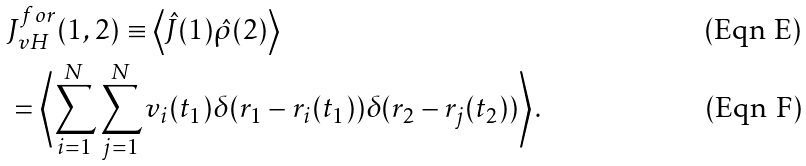Convert formula to latex. <formula><loc_0><loc_0><loc_500><loc_500>& J _ { v H } ^ { f o r } ( 1 , 2 ) \equiv \left \langle \hat { J } ( 1 ) \hat { \rho } ( 2 ) \right \rangle \\ & = \left \langle \sum _ { i = 1 } ^ { N } \sum _ { j = 1 } ^ { N } v _ { i } ( t _ { 1 } ) \delta ( r _ { 1 } - r _ { i } ( t _ { 1 } ) ) \delta ( r _ { 2 } - r _ { j } ( t _ { 2 } ) ) \right \rangle .</formula> 